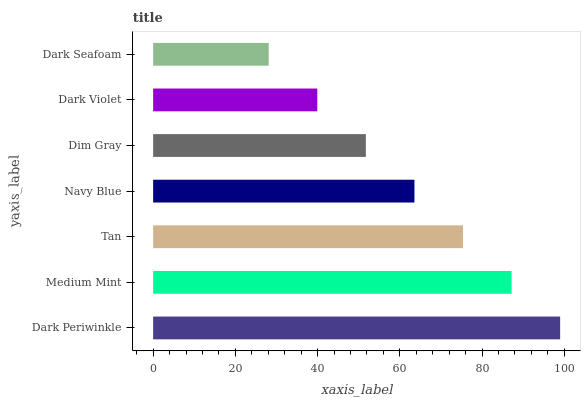Is Dark Seafoam the minimum?
Answer yes or no. Yes. Is Dark Periwinkle the maximum?
Answer yes or no. Yes. Is Medium Mint the minimum?
Answer yes or no. No. Is Medium Mint the maximum?
Answer yes or no. No. Is Dark Periwinkle greater than Medium Mint?
Answer yes or no. Yes. Is Medium Mint less than Dark Periwinkle?
Answer yes or no. Yes. Is Medium Mint greater than Dark Periwinkle?
Answer yes or no. No. Is Dark Periwinkle less than Medium Mint?
Answer yes or no. No. Is Navy Blue the high median?
Answer yes or no. Yes. Is Navy Blue the low median?
Answer yes or no. Yes. Is Dark Violet the high median?
Answer yes or no. No. Is Medium Mint the low median?
Answer yes or no. No. 